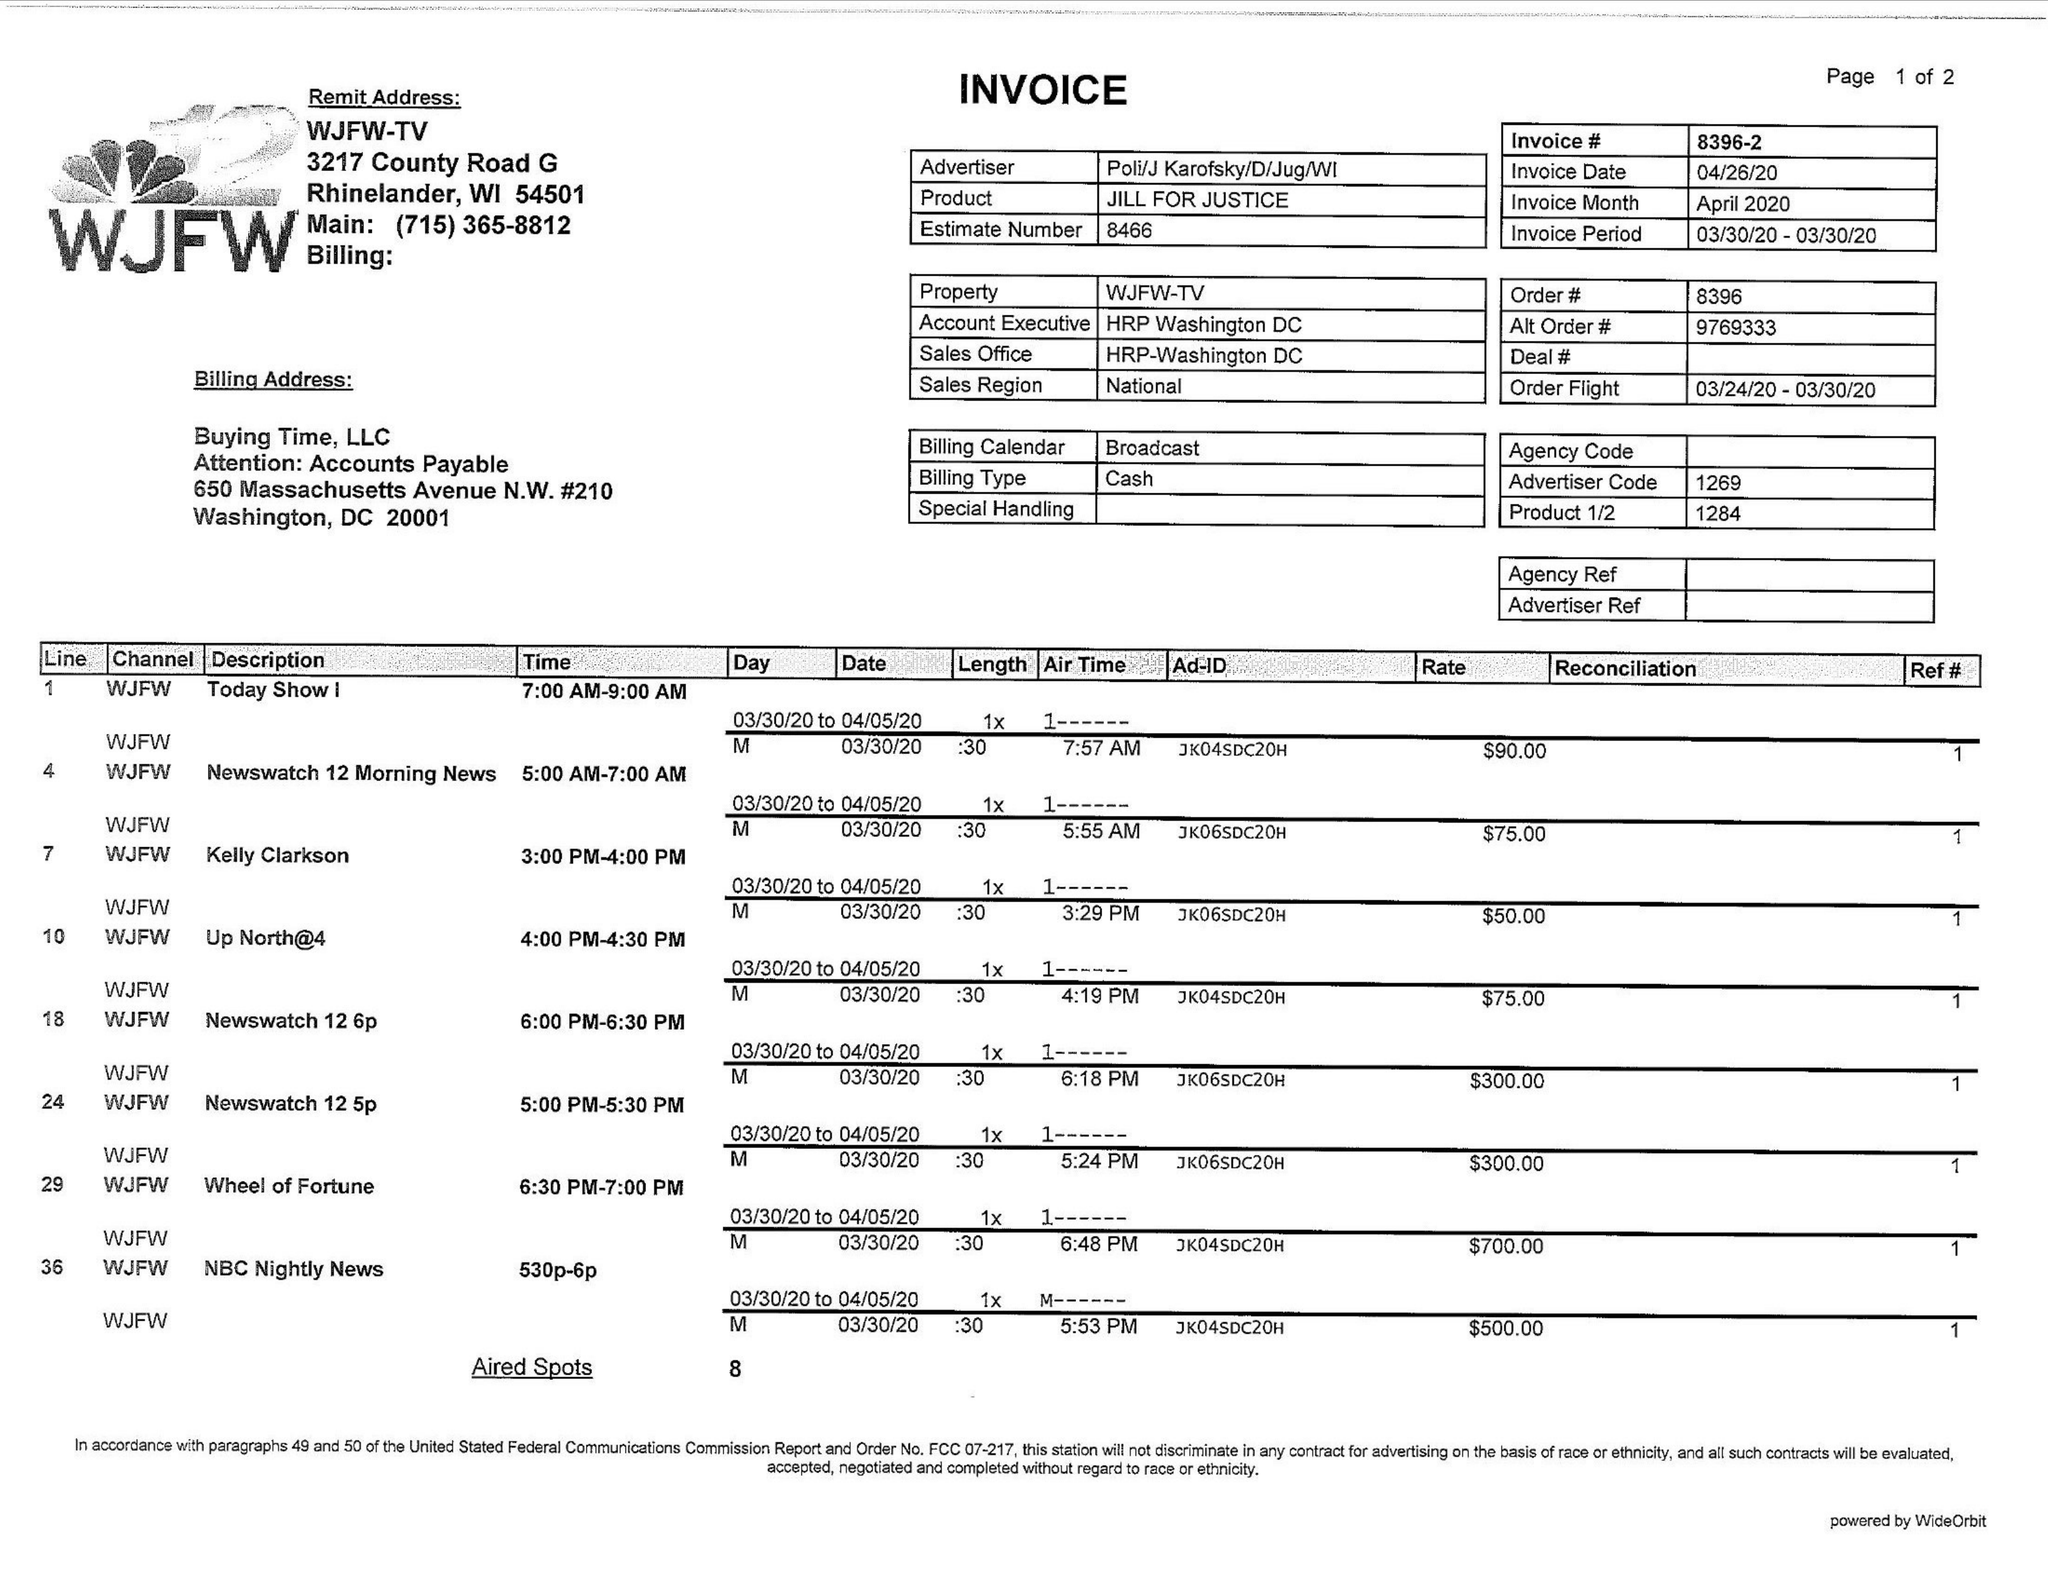What is the value for the gross_amount?
Answer the question using a single word or phrase. 2090.00 